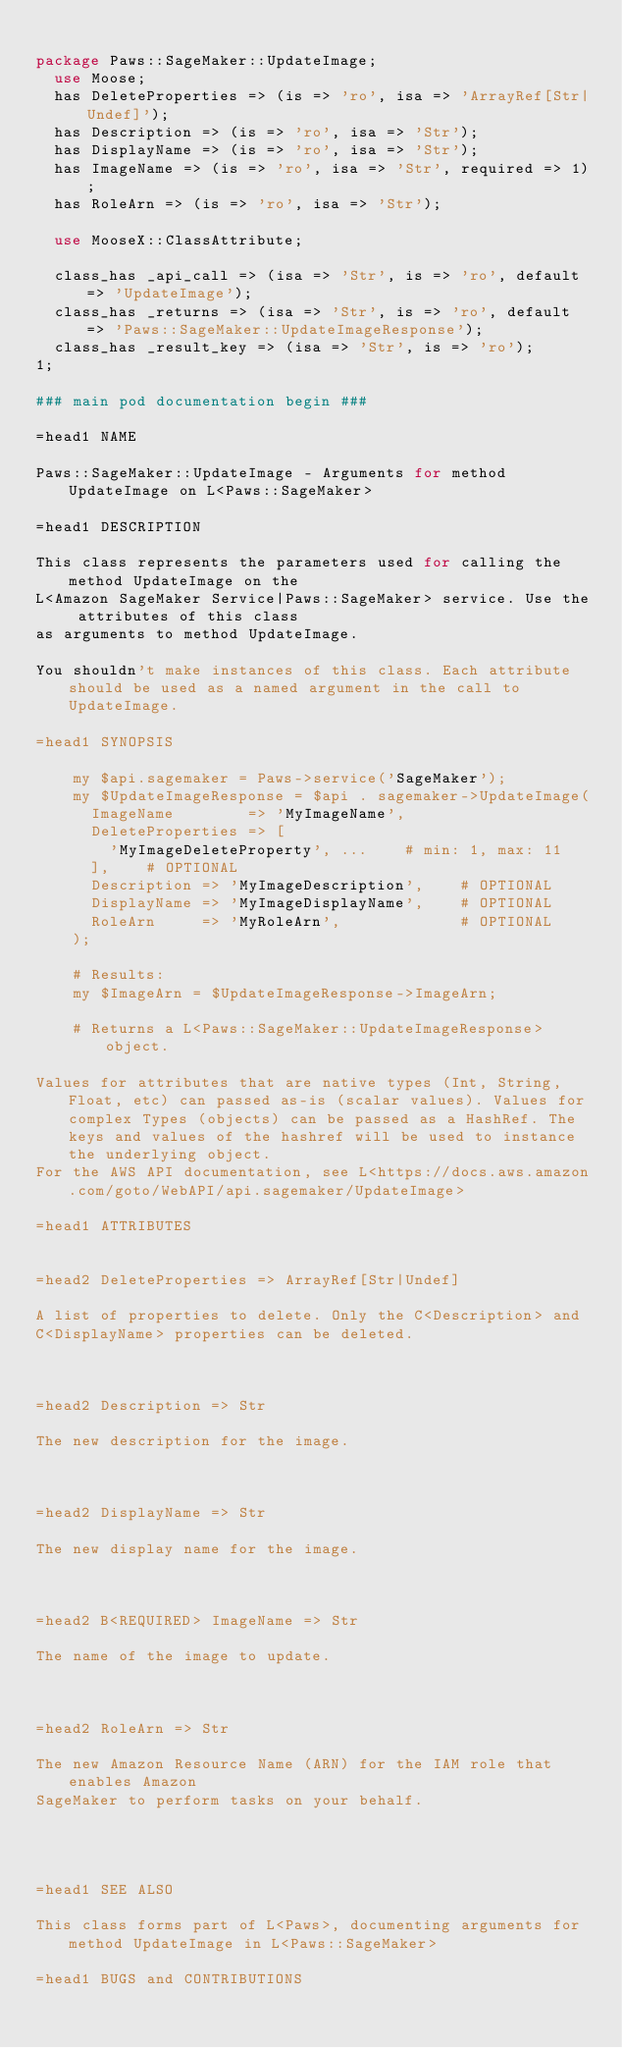Convert code to text. <code><loc_0><loc_0><loc_500><loc_500><_Perl_>
package Paws::SageMaker::UpdateImage;
  use Moose;
  has DeleteProperties => (is => 'ro', isa => 'ArrayRef[Str|Undef]');
  has Description => (is => 'ro', isa => 'Str');
  has DisplayName => (is => 'ro', isa => 'Str');
  has ImageName => (is => 'ro', isa => 'Str', required => 1);
  has RoleArn => (is => 'ro', isa => 'Str');

  use MooseX::ClassAttribute;

  class_has _api_call => (isa => 'Str', is => 'ro', default => 'UpdateImage');
  class_has _returns => (isa => 'Str', is => 'ro', default => 'Paws::SageMaker::UpdateImageResponse');
  class_has _result_key => (isa => 'Str', is => 'ro');
1;

### main pod documentation begin ###

=head1 NAME

Paws::SageMaker::UpdateImage - Arguments for method UpdateImage on L<Paws::SageMaker>

=head1 DESCRIPTION

This class represents the parameters used for calling the method UpdateImage on the
L<Amazon SageMaker Service|Paws::SageMaker> service. Use the attributes of this class
as arguments to method UpdateImage.

You shouldn't make instances of this class. Each attribute should be used as a named argument in the call to UpdateImage.

=head1 SYNOPSIS

    my $api.sagemaker = Paws->service('SageMaker');
    my $UpdateImageResponse = $api . sagemaker->UpdateImage(
      ImageName        => 'MyImageName',
      DeleteProperties => [
        'MyImageDeleteProperty', ...    # min: 1, max: 11
      ],    # OPTIONAL
      Description => 'MyImageDescription',    # OPTIONAL
      DisplayName => 'MyImageDisplayName',    # OPTIONAL
      RoleArn     => 'MyRoleArn',             # OPTIONAL
    );

    # Results:
    my $ImageArn = $UpdateImageResponse->ImageArn;

    # Returns a L<Paws::SageMaker::UpdateImageResponse> object.

Values for attributes that are native types (Int, String, Float, etc) can passed as-is (scalar values). Values for complex Types (objects) can be passed as a HashRef. The keys and values of the hashref will be used to instance the underlying object.
For the AWS API documentation, see L<https://docs.aws.amazon.com/goto/WebAPI/api.sagemaker/UpdateImage>

=head1 ATTRIBUTES


=head2 DeleteProperties => ArrayRef[Str|Undef]

A list of properties to delete. Only the C<Description> and
C<DisplayName> properties can be deleted.



=head2 Description => Str

The new description for the image.



=head2 DisplayName => Str

The new display name for the image.



=head2 B<REQUIRED> ImageName => Str

The name of the image to update.



=head2 RoleArn => Str

The new Amazon Resource Name (ARN) for the IAM role that enables Amazon
SageMaker to perform tasks on your behalf.




=head1 SEE ALSO

This class forms part of L<Paws>, documenting arguments for method UpdateImage in L<Paws::SageMaker>

=head1 BUGS and CONTRIBUTIONS
</code> 